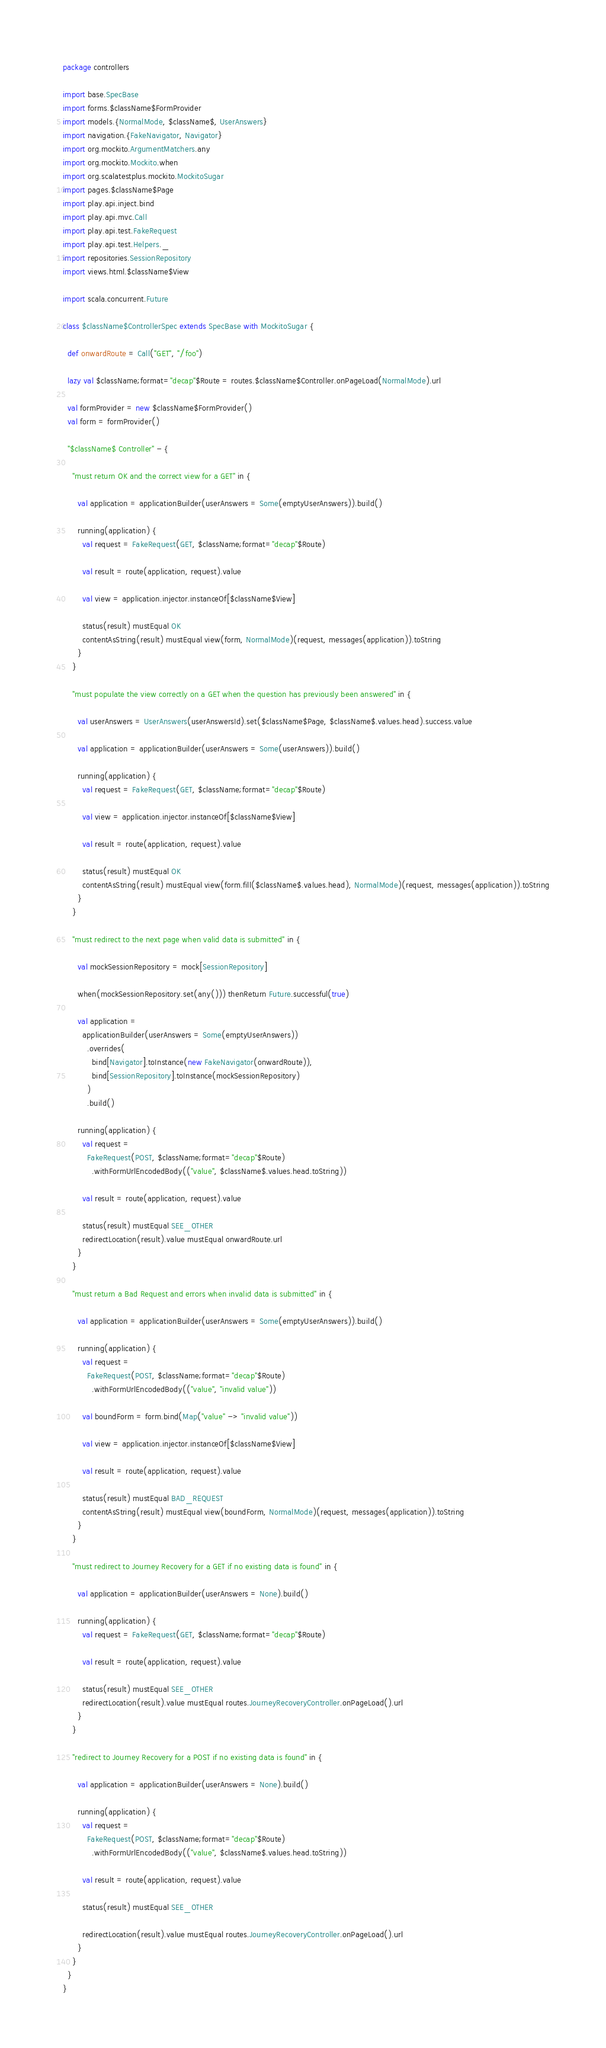Convert code to text. <code><loc_0><loc_0><loc_500><loc_500><_Scala_>package controllers

import base.SpecBase
import forms.$className$FormProvider
import models.{NormalMode, $className$, UserAnswers}
import navigation.{FakeNavigator, Navigator}
import org.mockito.ArgumentMatchers.any
import org.mockito.Mockito.when
import org.scalatestplus.mockito.MockitoSugar
import pages.$className$Page
import play.api.inject.bind
import play.api.mvc.Call
import play.api.test.FakeRequest
import play.api.test.Helpers._
import repositories.SessionRepository
import views.html.$className$View

import scala.concurrent.Future

class $className$ControllerSpec extends SpecBase with MockitoSugar {

  def onwardRoute = Call("GET", "/foo")

  lazy val $className;format="decap"$Route = routes.$className$Controller.onPageLoad(NormalMode).url

  val formProvider = new $className$FormProvider()
  val form = formProvider()

  "$className$ Controller" - {

    "must return OK and the correct view for a GET" in {

      val application = applicationBuilder(userAnswers = Some(emptyUserAnswers)).build()

      running(application) {
        val request = FakeRequest(GET, $className;format="decap"$Route)

        val result = route(application, request).value

        val view = application.injector.instanceOf[$className$View]

        status(result) mustEqual OK
        contentAsString(result) mustEqual view(form, NormalMode)(request, messages(application)).toString
      }
    }

    "must populate the view correctly on a GET when the question has previously been answered" in {

      val userAnswers = UserAnswers(userAnswersId).set($className$Page, $className$.values.head).success.value

      val application = applicationBuilder(userAnswers = Some(userAnswers)).build()

      running(application) {
        val request = FakeRequest(GET, $className;format="decap"$Route)

        val view = application.injector.instanceOf[$className$View]

        val result = route(application, request).value

        status(result) mustEqual OK
        contentAsString(result) mustEqual view(form.fill($className$.values.head), NormalMode)(request, messages(application)).toString
      }
    }

    "must redirect to the next page when valid data is submitted" in {

      val mockSessionRepository = mock[SessionRepository]

      when(mockSessionRepository.set(any())) thenReturn Future.successful(true)

      val application =
        applicationBuilder(userAnswers = Some(emptyUserAnswers))
          .overrides(
            bind[Navigator].toInstance(new FakeNavigator(onwardRoute)),
            bind[SessionRepository].toInstance(mockSessionRepository)
          )
          .build()

      running(application) {
        val request =
          FakeRequest(POST, $className;format="decap"$Route)
            .withFormUrlEncodedBody(("value", $className$.values.head.toString))

        val result = route(application, request).value

        status(result) mustEqual SEE_OTHER
        redirectLocation(result).value mustEqual onwardRoute.url
      }
    }

    "must return a Bad Request and errors when invalid data is submitted" in {

      val application = applicationBuilder(userAnswers = Some(emptyUserAnswers)).build()

      running(application) {
        val request =
          FakeRequest(POST, $className;format="decap"$Route)
            .withFormUrlEncodedBody(("value", "invalid value"))

        val boundForm = form.bind(Map("value" -> "invalid value"))

        val view = application.injector.instanceOf[$className$View]

        val result = route(application, request).value

        status(result) mustEqual BAD_REQUEST
        contentAsString(result) mustEqual view(boundForm, NormalMode)(request, messages(application)).toString
      }
    }

    "must redirect to Journey Recovery for a GET if no existing data is found" in {

      val application = applicationBuilder(userAnswers = None).build()

      running(application) {
        val request = FakeRequest(GET, $className;format="decap"$Route)

        val result = route(application, request).value

        status(result) mustEqual SEE_OTHER
        redirectLocation(result).value mustEqual routes.JourneyRecoveryController.onPageLoad().url
      }
    }

    "redirect to Journey Recovery for a POST if no existing data is found" in {
      
      val application = applicationBuilder(userAnswers = None).build()

      running(application) {
        val request =
          FakeRequest(POST, $className;format="decap"$Route)
            .withFormUrlEncodedBody(("value", $className$.values.head.toString))

        val result = route(application, request).value

        status(result) mustEqual SEE_OTHER

        redirectLocation(result).value mustEqual routes.JourneyRecoveryController.onPageLoad().url
      }
    }
  }
}
</code> 